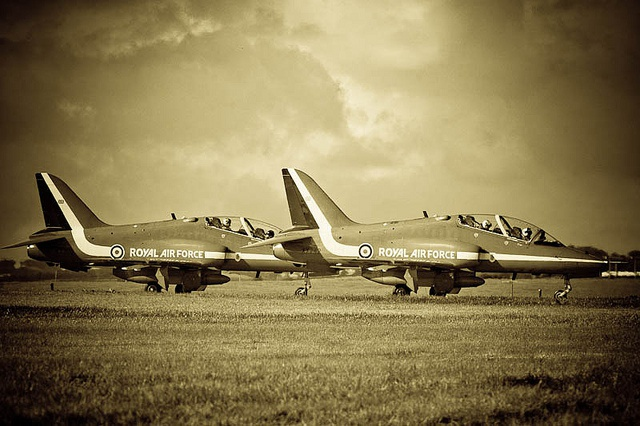Describe the objects in this image and their specific colors. I can see airplane in black, tan, olive, and beige tones, airplane in black and olive tones, people in black, tan, khaki, and olive tones, people in black, olive, and tan tones, and people in black, beige, and olive tones in this image. 